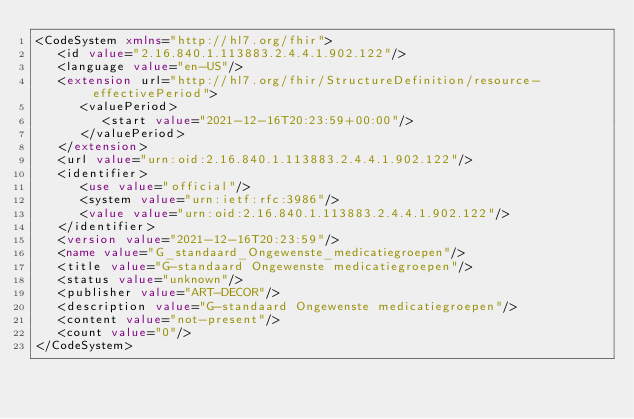<code> <loc_0><loc_0><loc_500><loc_500><_XML_><CodeSystem xmlns="http://hl7.org/fhir">
   <id value="2.16.840.1.113883.2.4.4.1.902.122"/>
   <language value="en-US"/>
   <extension url="http://hl7.org/fhir/StructureDefinition/resource-effectivePeriod">
      <valuePeriod>
         <start value="2021-12-16T20:23:59+00:00"/>
      </valuePeriod>
   </extension>
   <url value="urn:oid:2.16.840.1.113883.2.4.4.1.902.122"/>
   <identifier>
      <use value="official"/>
      <system value="urn:ietf:rfc:3986"/>
      <value value="urn:oid:2.16.840.1.113883.2.4.4.1.902.122"/>
   </identifier>
   <version value="2021-12-16T20:23:59"/>
   <name value="G_standaard_Ongewenste_medicatiegroepen"/>
   <title value="G-standaard Ongewenste medicatiegroepen"/>
   <status value="unknown"/>
   <publisher value="ART-DECOR"/>
   <description value="G-standaard Ongewenste medicatiegroepen"/>
   <content value="not-present"/>
   <count value="0"/>
</CodeSystem>
</code> 